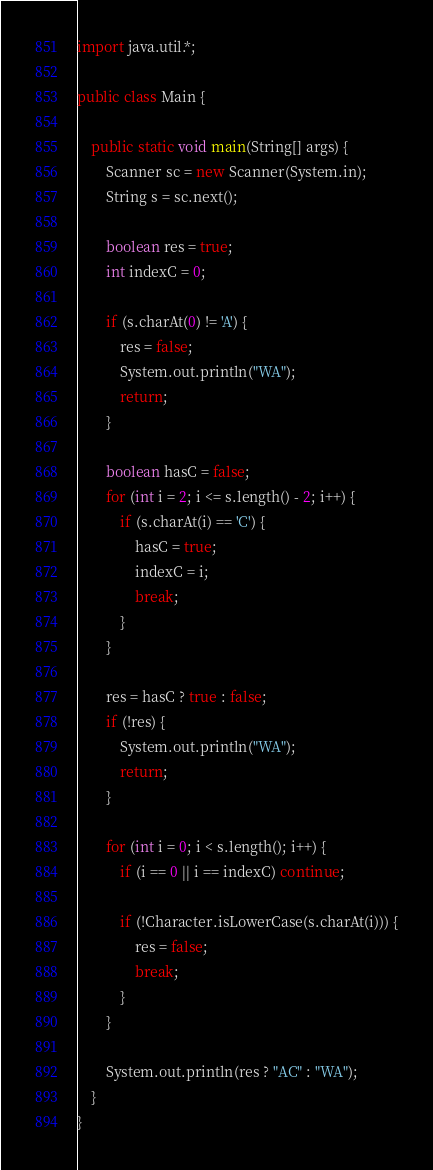Convert code to text. <code><loc_0><loc_0><loc_500><loc_500><_Java_>import java.util.*;

public class Main {

    public static void main(String[] args) {
        Scanner sc = new Scanner(System.in);
        String s = sc.next();

        boolean res = true;
        int indexC = 0;

        if (s.charAt(0) != 'A') {
            res = false;
            System.out.println("WA");
            return;
        }

        boolean hasC = false;
        for (int i = 2; i <= s.length() - 2; i++) {
            if (s.charAt(i) == 'C') {
                hasC = true;
                indexC = i;
                break;
            }
        }

        res = hasC ? true : false;
        if (!res) {
            System.out.println("WA");
            return;
        }

        for (int i = 0; i < s.length(); i++) {
            if (i == 0 || i == indexC) continue;

            if (!Character.isLowerCase(s.charAt(i))) {
                res = false;
                break;
            }
        }

        System.out.println(res ? "AC" : "WA");
    }
}
</code> 